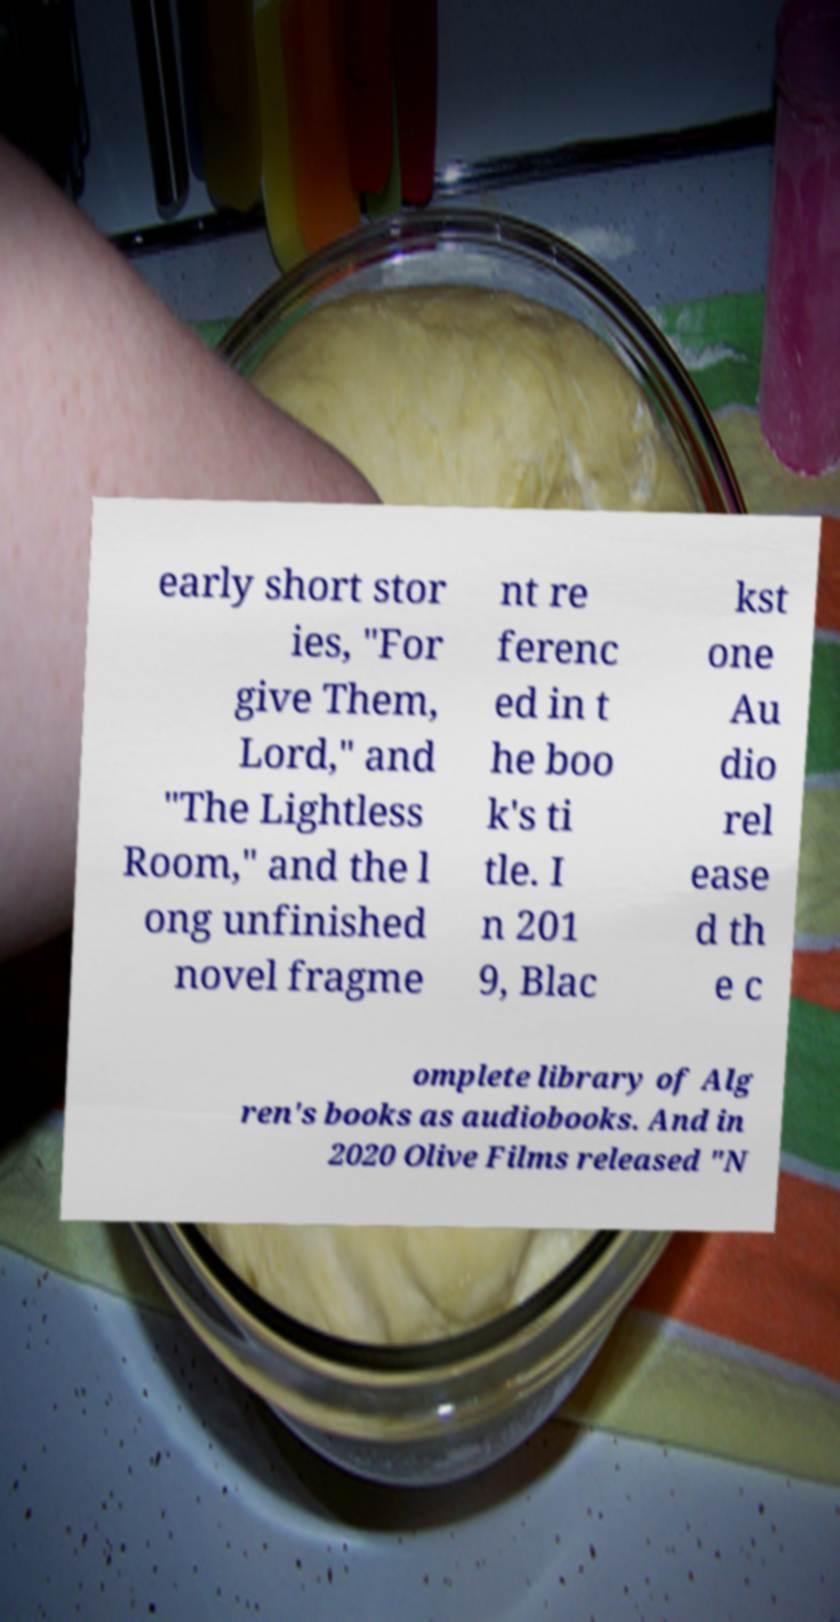Please identify and transcribe the text found in this image. early short stor ies, "For give Them, Lord," and "The Lightless Room," and the l ong unfinished novel fragme nt re ferenc ed in t he boo k's ti tle. I n 201 9, Blac kst one Au dio rel ease d th e c omplete library of Alg ren's books as audiobooks. And in 2020 Olive Films released "N 